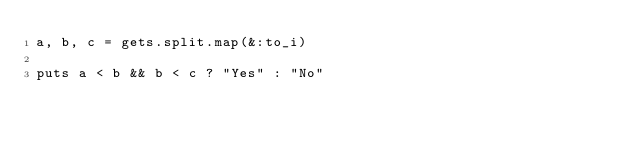Convert code to text. <code><loc_0><loc_0><loc_500><loc_500><_Ruby_>a, b, c = gets.split.map(&:to_i)

puts a < b && b < c ? "Yes" : "No"</code> 